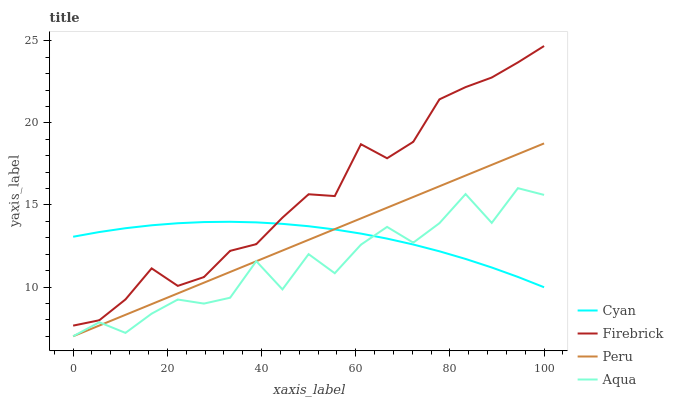Does Aqua have the minimum area under the curve?
Answer yes or no. Yes. Does Firebrick have the maximum area under the curve?
Answer yes or no. Yes. Does Firebrick have the minimum area under the curve?
Answer yes or no. No. Does Aqua have the maximum area under the curve?
Answer yes or no. No. Is Peru the smoothest?
Answer yes or no. Yes. Is Aqua the roughest?
Answer yes or no. Yes. Is Firebrick the smoothest?
Answer yes or no. No. Is Firebrick the roughest?
Answer yes or no. No. Does Aqua have the lowest value?
Answer yes or no. Yes. Does Firebrick have the lowest value?
Answer yes or no. No. Does Firebrick have the highest value?
Answer yes or no. Yes. Does Aqua have the highest value?
Answer yes or no. No. Is Peru less than Firebrick?
Answer yes or no. Yes. Is Firebrick greater than Peru?
Answer yes or no. Yes. Does Firebrick intersect Cyan?
Answer yes or no. Yes. Is Firebrick less than Cyan?
Answer yes or no. No. Is Firebrick greater than Cyan?
Answer yes or no. No. Does Peru intersect Firebrick?
Answer yes or no. No. 